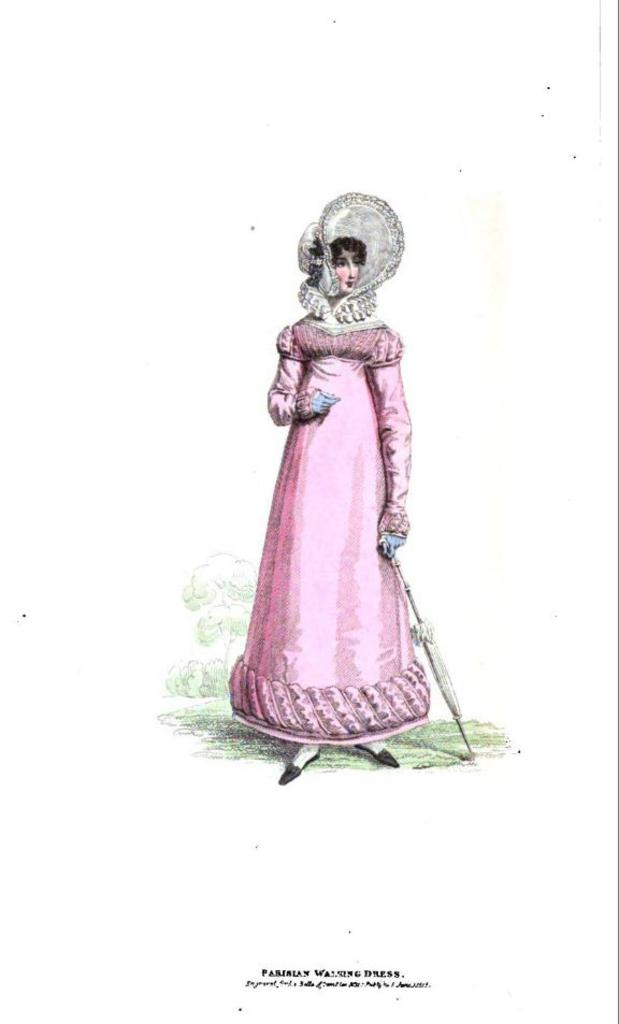What is the main subject of the painting? The painting depicts a lady. What is the lady wearing in the painting? The lady is wearing a pink gown and a hat. What object is the lady holding in the painting? The lady is holding an umbrella. What can be seen in the background of the painting? There are trees in the background of the painting. Are there any words or text in the painting? Yes, there are some texts at the bottom of the painting. What type of yarn is the lady using to knit in the painting? There is no yarn or knitting depicted in the painting; the lady is holding an umbrella. What kind of noise can be heard coming from the trees in the background of the painting? The painting is a still image and does not depict any sounds or noises. 